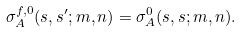<formula> <loc_0><loc_0><loc_500><loc_500>\sigma _ { A } ^ { f , 0 } ( s , s ^ { \prime } ; m , n ) = \sigma _ { A } ^ { 0 } ( s , s ; m , n ) .</formula> 